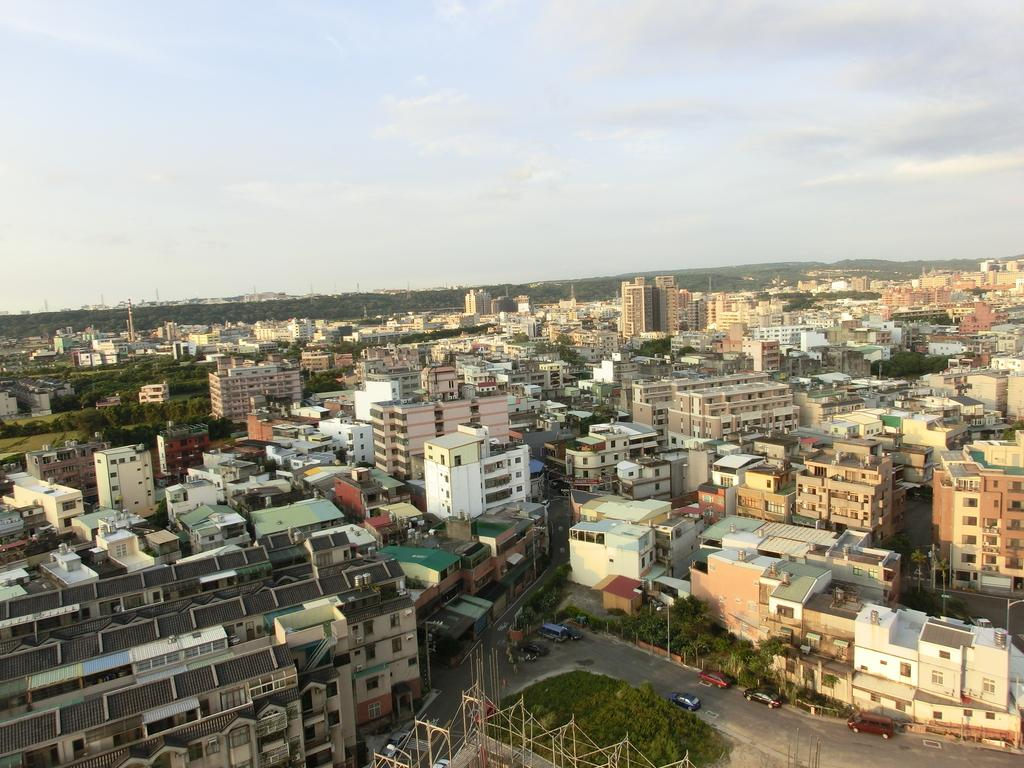What type of structures can be seen in the image? There are buildings in the image. What other natural elements are present in the image? There are trees in the image. What is the purpose of the pathway visible in the image? There is a road in the image, which is likely used for transportation. What is visible at the top of the image? The sky is visible at the top of the image, and there are clouds in the sky. What type of transportation can be seen on the road? There are vehicles on the road in the image. Where is the grass located in the image? There is no grass present in the image. What type of army is depicted in the image? There is no army or military presence depicted in the image. 